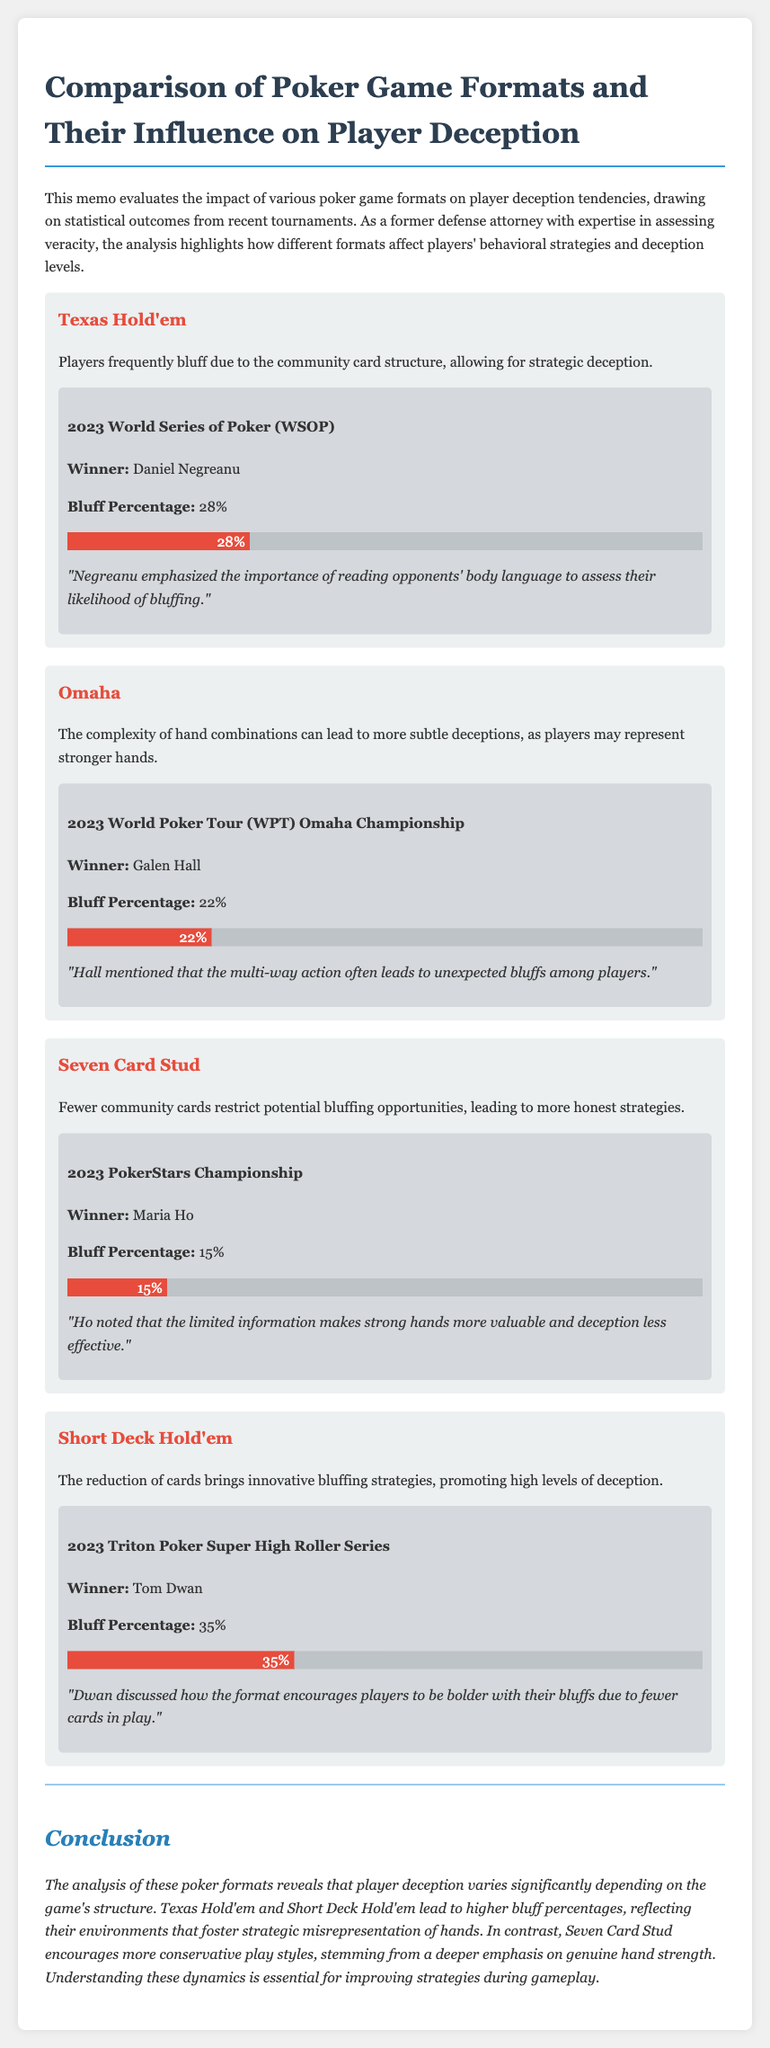What is the bluff percentage in Texas Hold'em? The bluff percentage for Texas Hold'em in the document is specified in the 2023 WSOP results.
Answer: 28% Who won the 2023 World Poker Tour Omaha Championship? The winner of the 2023 WPT Omaha Championship is mentioned in the format section dedicated to Omaha.
Answer: Galen Hall What unique characteristic does Seven Card Stud have regarding bluffing? The document states that Seven Card Stud has fewer community cards, which limits bluffing opportunities.
Answer: Restricts bluffing opportunities What is the bluff percentage in Seven Card Stud? The specific bluff percentage for Seven Card Stud is provided under the associated tournament details.
Answer: 15% Which poker format had the highest bluff percentage? The document compares the bluff percentages of various formats, highlighting the one with the highest figure.
Answer: Short Deck Hold'em What strategy does Tom Dwan attribute to the Short Deck Hold'em format? The memo includes a quote from Tom Dwan about how the format encourages certain strategies.
Answer: Innovative bluffing strategies Why is player deception lower in Seven Card Stud compared to other formats? The reasoning for lower deception levels in Seven Card Stud is explained in the context of the game structure.
Answer: More honest strategies What was the winner of the 2023 Triton Poker Super High Roller Series? The document lists the winner under the Short Deck Hold'em format section.
Answer: Tom Dwan What conclusion does the memo draw about poker formats and player deception? The concluding section summarizes the impact of game structure on bluffing tendencies.
Answer: Varies significantly depending on the game's structure 